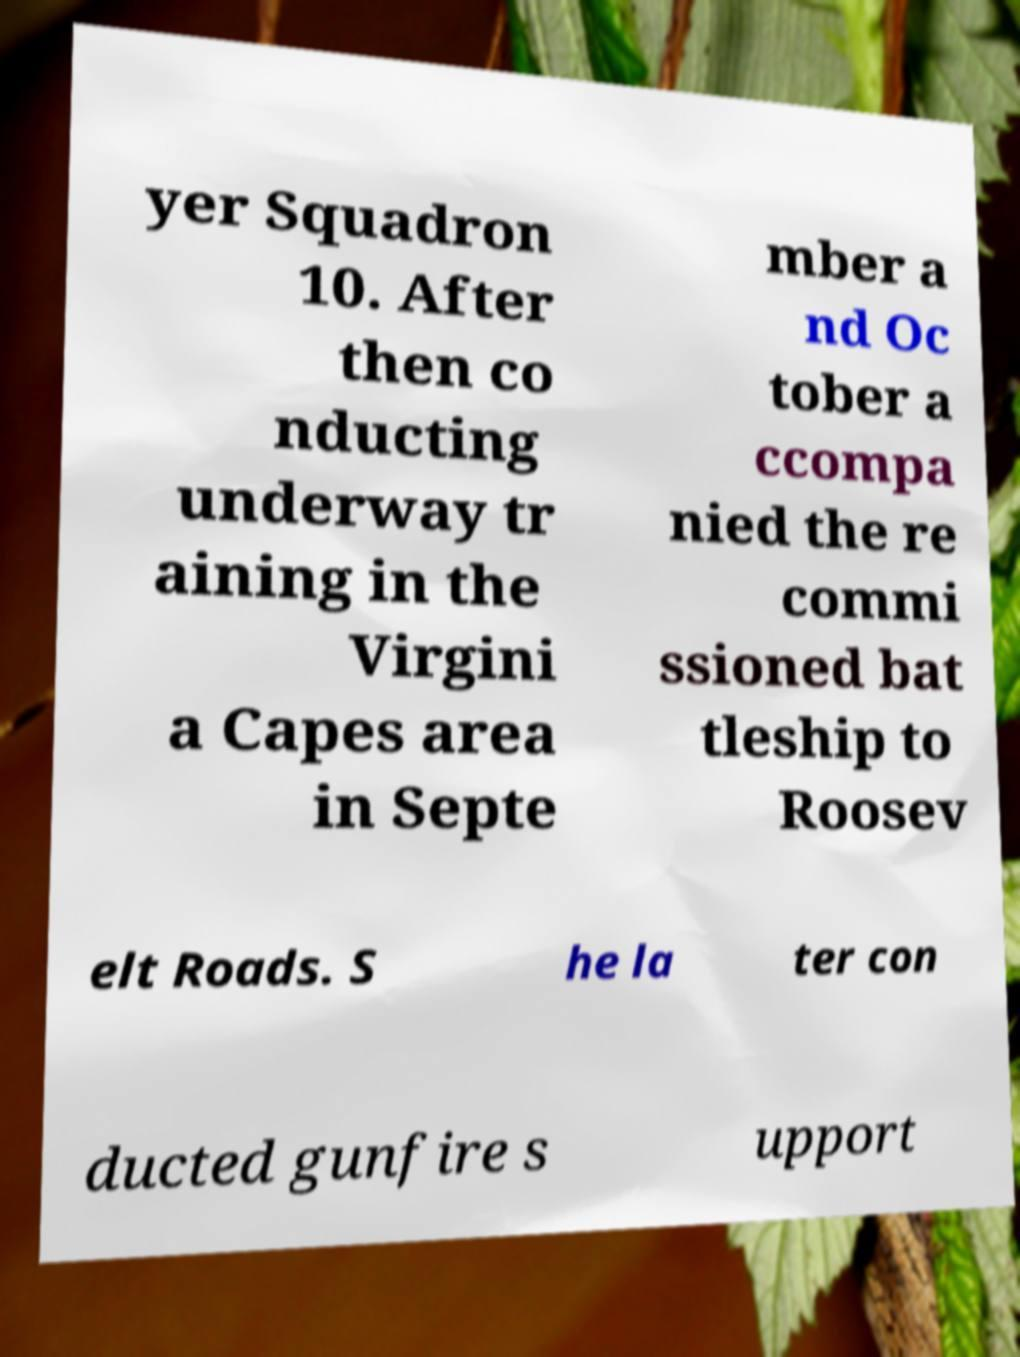Can you read and provide the text displayed in the image?This photo seems to have some interesting text. Can you extract and type it out for me? yer Squadron 10. After then co nducting underway tr aining in the Virgini a Capes area in Septe mber a nd Oc tober a ccompa nied the re commi ssioned bat tleship to Roosev elt Roads. S he la ter con ducted gunfire s upport 